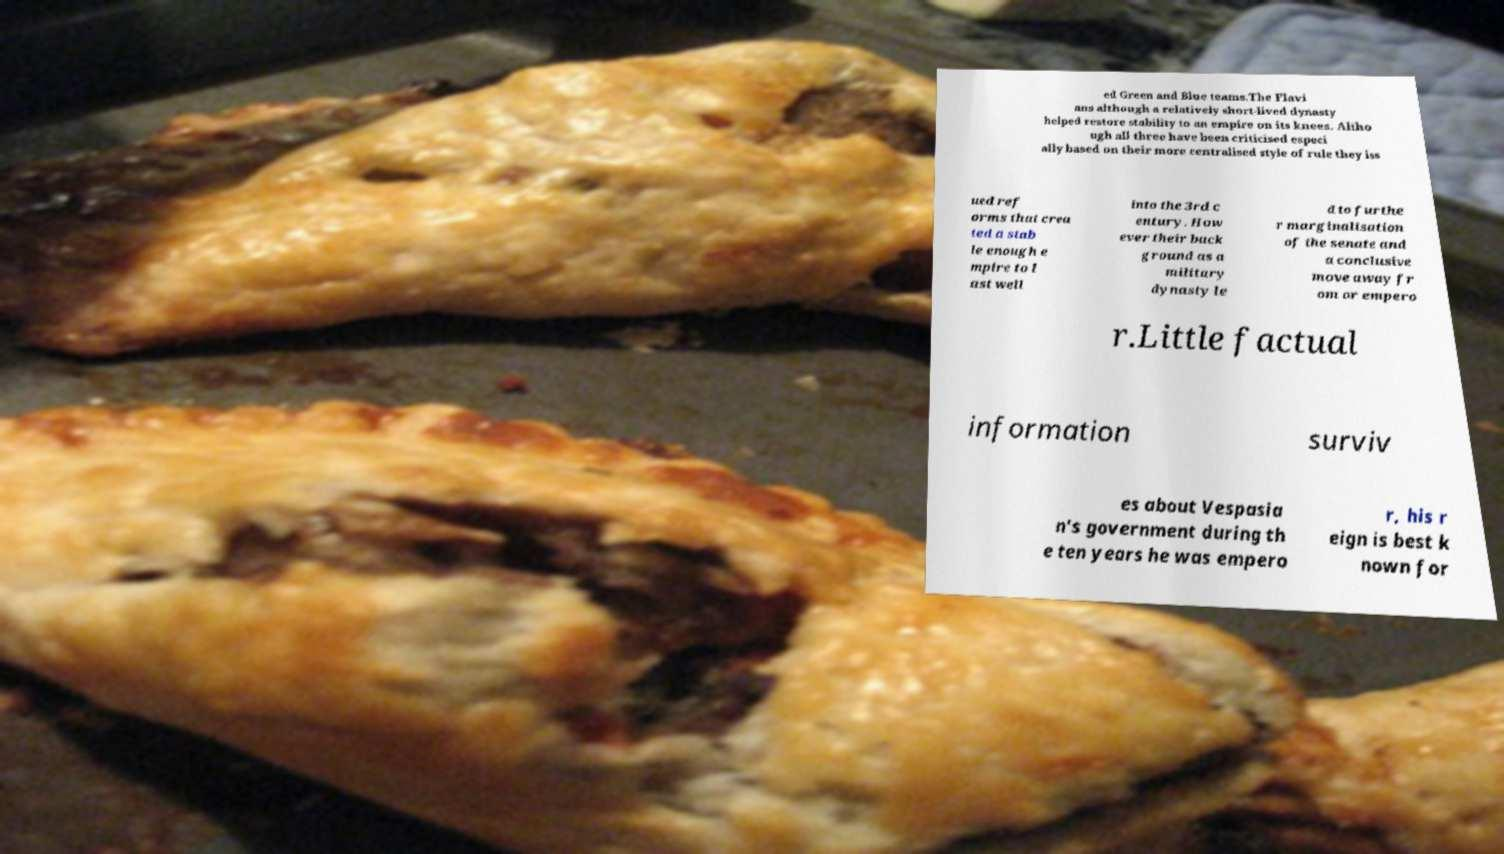Could you assist in decoding the text presented in this image and type it out clearly? ed Green and Blue teams.The Flavi ans although a relatively short-lived dynasty helped restore stability to an empire on its knees. Altho ugh all three have been criticised especi ally based on their more centralised style of rule they iss ued ref orms that crea ted a stab le enough e mpire to l ast well into the 3rd c entury. How ever their back ground as a military dynasty le d to furthe r marginalisation of the senate and a conclusive move away fr om or empero r.Little factual information surviv es about Vespasia n's government during th e ten years he was empero r, his r eign is best k nown for 